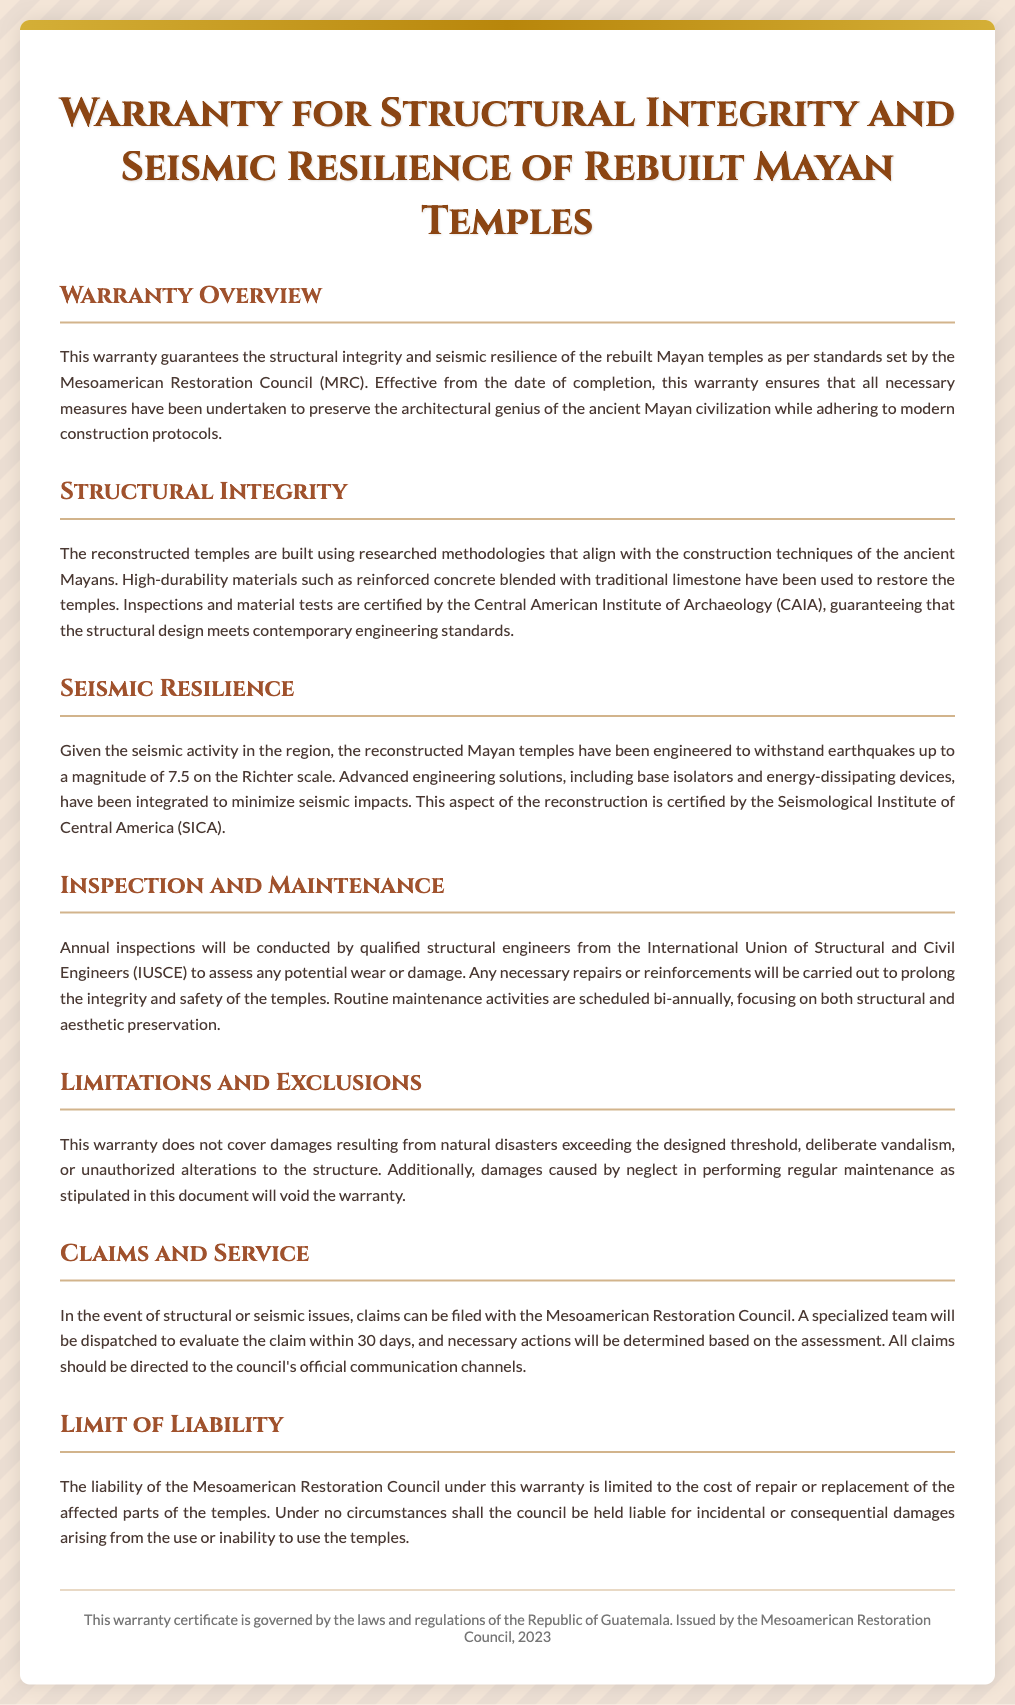What is the title of the document? The title is stated at the top of the warranty document, which is the main subject of the document.
Answer: Warranty for Structural Integrity and Seismic Resilience of Rebuilt Mayan Temples Who guarantees the structural integrity? The entity responsible for the warranty is mentioned as the organization overseeing the construction and preservation efforts.
Answer: Mesoamerican Restoration Council What magnitude of earthquakes can the temples withstand? This information details the seismic resilience aspect of the warranty, specifying the tested capacity against natural disasters.
Answer: 7.5 Which institute certified the material tests? This specifies the organization responsible for ensuring the materials used in the reconstruction meet the necessary requirements.
Answer: Central American Institute of Archaeology How often will routine maintenance activities be scheduled? This highlights the frequency of maintenance actions required to keep the temples in good condition as part of the warranty terms.
Answer: Bi-annually What does the warranty exclude? This identifies conditions or circumstances that the warranty does not cover, providing clarity on the limitations.
Answer: Natural disasters exceeding the designed threshold What is the response time for claims evaluation? This indicates the timeframe within which the warranty claims will be acted upon, ensuring timely responses for structural concerns.
Answer: 30 days What is the limit of liability for the Mesoamerican Restoration Council? This refers to the extent of financial responsibility of the council under the warranty conditions.
Answer: Cost of repair or replacement 